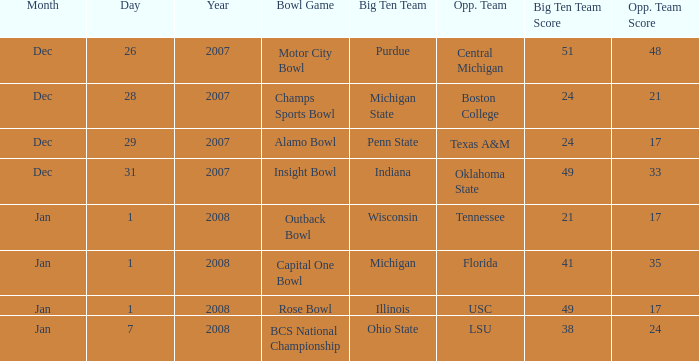What was the score of the Insight Bowl? 49-33. 